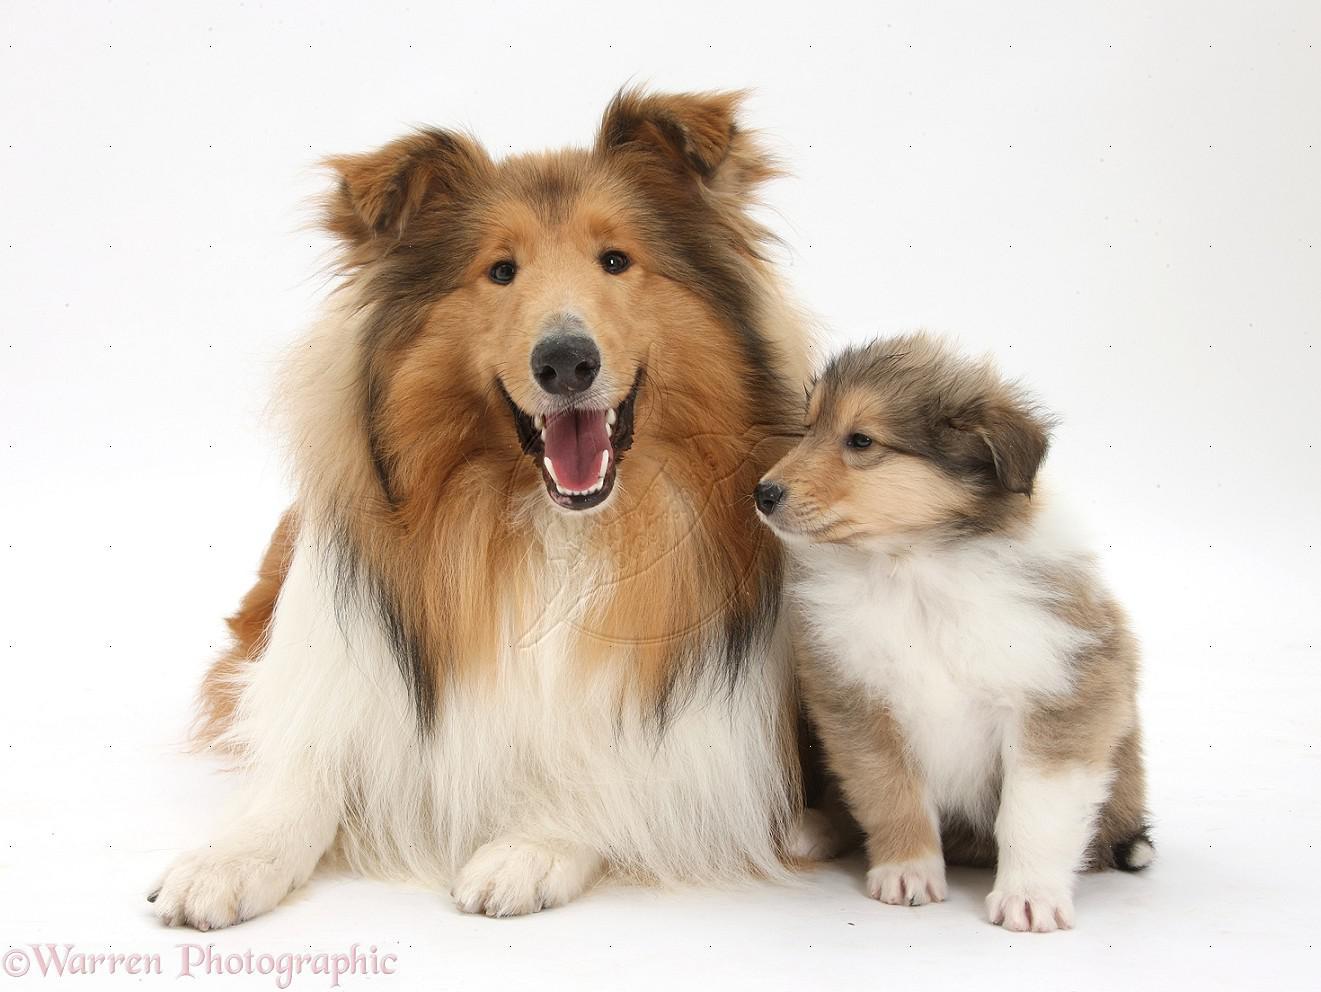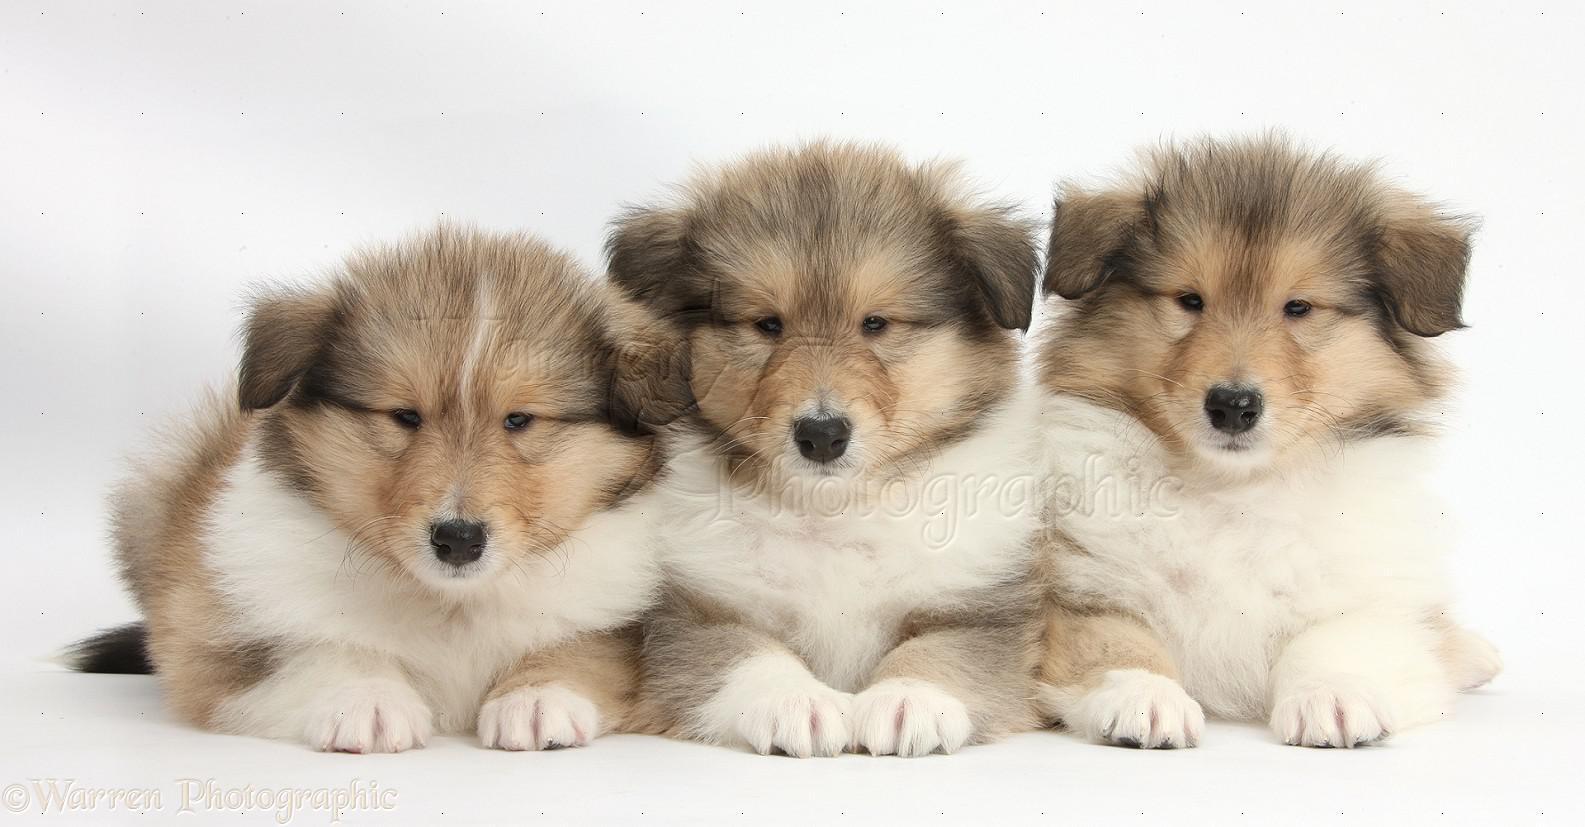The first image is the image on the left, the second image is the image on the right. Given the left and right images, does the statement "There are three dogs in total." hold true? Answer yes or no. No. The first image is the image on the left, the second image is the image on the right. Analyze the images presented: Is the assertion "Left and right images contain a collie pup that looks the other's twin, and the combined images show at least three of these look-alike pups." valid? Answer yes or no. Yes. 